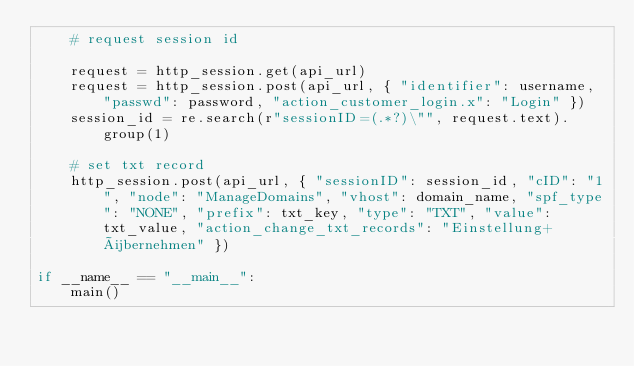<code> <loc_0><loc_0><loc_500><loc_500><_Python_>    # request session id

    request = http_session.get(api_url)
    request = http_session.post(api_url, { "identifier": username, "passwd": password, "action_customer_login.x": "Login" })
    session_id = re.search(r"sessionID=(.*?)\"", request.text).group(1)

    # set txt record
    http_session.post(api_url, { "sessionID": session_id, "cID": "1", "node": "ManageDomains", "vhost": domain_name, "spf_type": "NONE", "prefix": txt_key, "type": "TXT", "value": txt_value, "action_change_txt_records": "Einstellung+übernehmen" })

if __name__ == "__main__":
    main()
</code> 